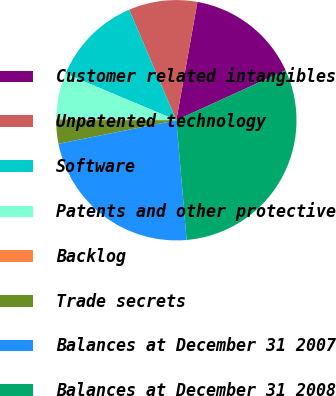<chart> <loc_0><loc_0><loc_500><loc_500><pie_chart><fcel>Customer related intangibles<fcel>Unpatented technology<fcel>Software<fcel>Patents and other protective<fcel>Backlog<fcel>Trade secrets<fcel>Balances at December 31 2007<fcel>Balances at December 31 2008<nl><fcel>15.37%<fcel>9.22%<fcel>12.25%<fcel>6.19%<fcel>0.13%<fcel>3.16%<fcel>23.23%<fcel>30.45%<nl></chart> 